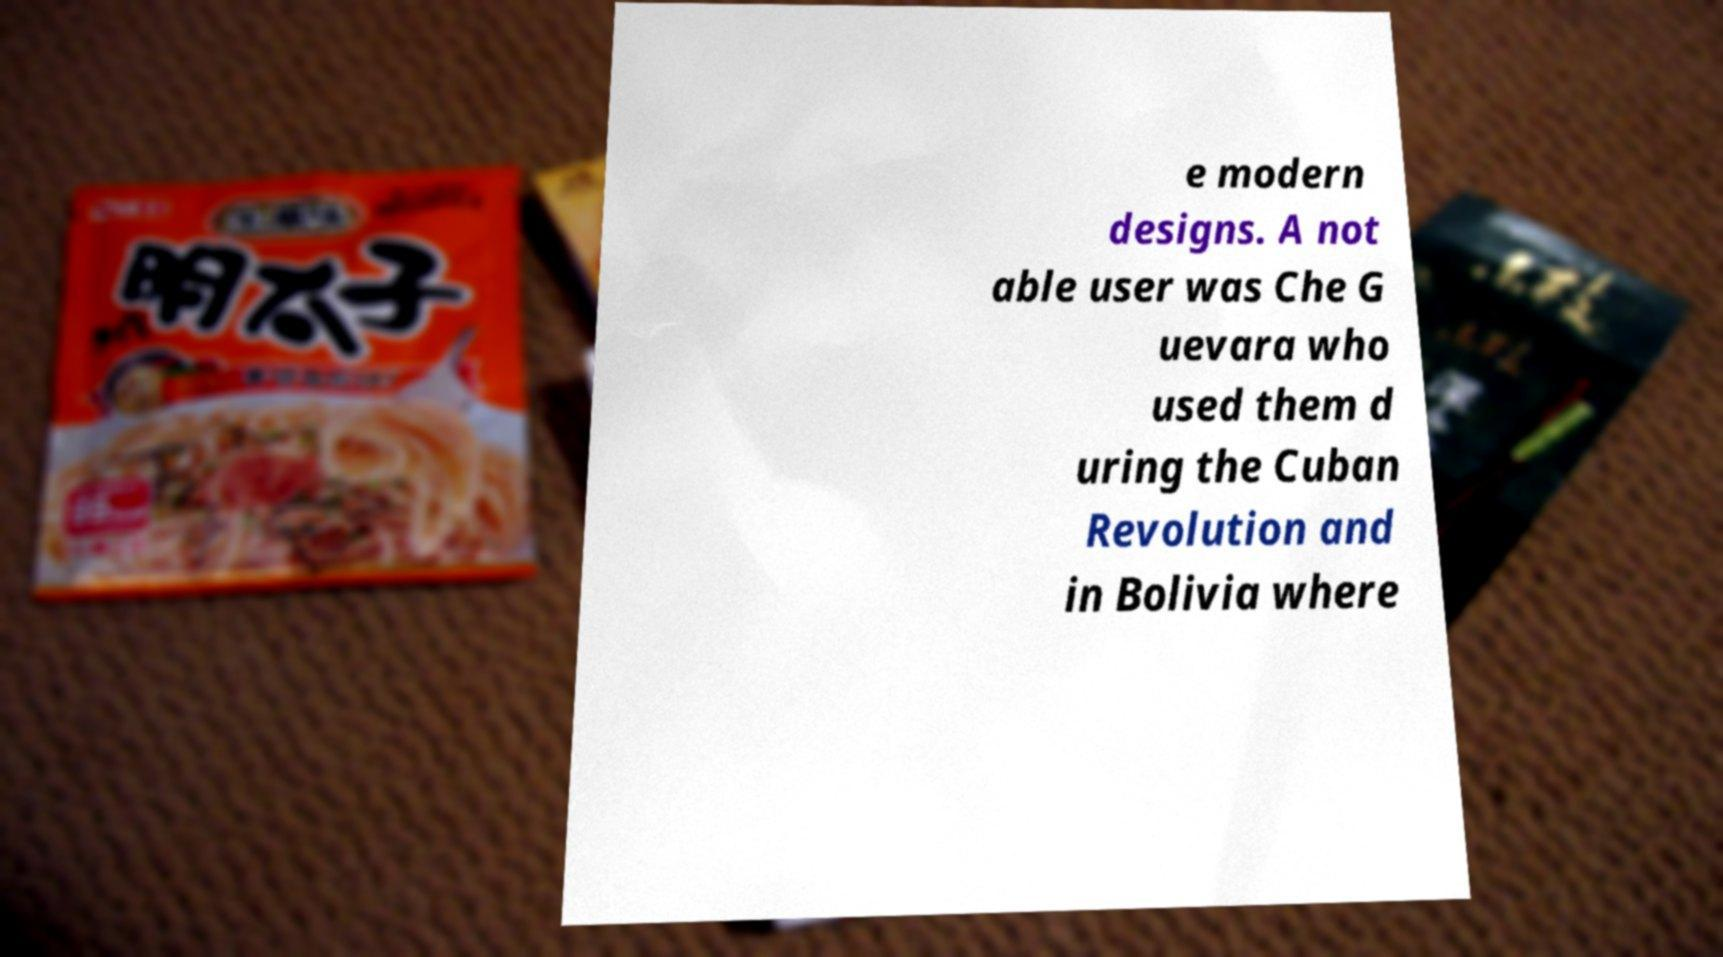Could you assist in decoding the text presented in this image and type it out clearly? e modern designs. A not able user was Che G uevara who used them d uring the Cuban Revolution and in Bolivia where 